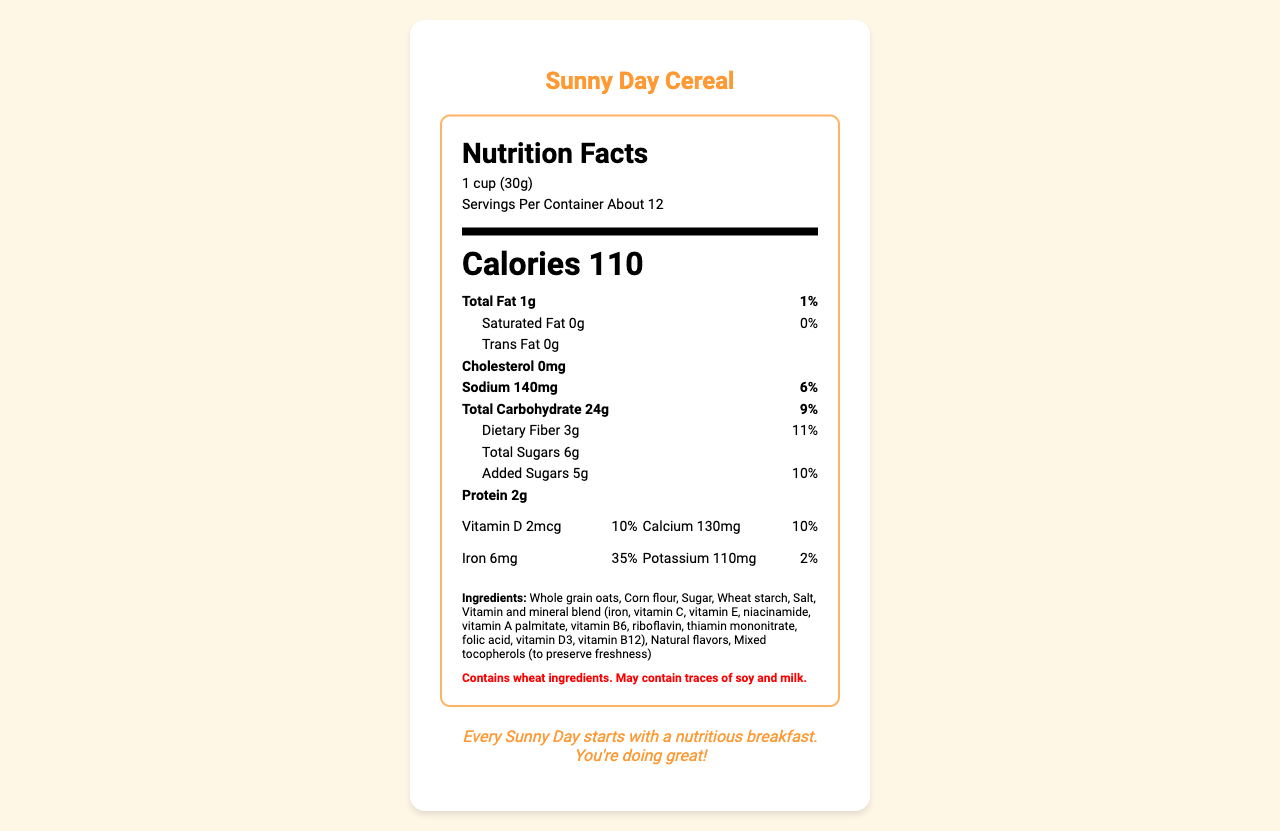what is the name of the product? The product name is displayed prominently at the top of the document.
Answer: Sunny Day Cereal how many servings are in the container? The number of servings per container is listed under the serving size information.
Answer: About 12 how many calories are in one serving? The number of calories per serving is listed prominently in bold near the top of the label.
Answer: 110 calories what is the serving size? The serving size is indicated below the title "Nutrition Facts."
Answer: 1 cup (30g) how much protein is in one serving? The protein content per serving is listed under the nutrition facts with other nutrients.
Answer: 2g what is the daily value percentage of iron in one serving? The percentage daily value of iron is listed under the vitamins section in the label.
Answer: 35% what vitamins and minerals are present in the cereal? A. Vitamin D, Calcium, Iron, Potassium B. Vitamin D, Calcium, Fiber, Vitamin A C. Potassium, Zinc, Fiber, Sugars D. Protein, Iron, Sugars, Potassium The listed nutrients include Vitamin D, Calcium, Iron, and Potassium.
Answer: A how much sodium is in one serving? A. 0mg B. 140mg C. 110mg D. 2mg The sodium content per serving is specified as 140mg.
Answer: B are there any artificial colors or flavors in the cereal? One of the marketing claims states "No artificial colors or flavors."
Answer: No is the breakfast cereal made with whole grains? One of the marketing claims states "Made with whole grains."
Answer: Yes what are some of the fun features for children? These features are listed under the child-friendly features section.
Answer: Colorful packaging with cartoon sun character, Fun, crunchy shapes, Mild, sweet flavor, Easy to eat with or without milk does the cereal contain any allergens? The allergen info mentions that the cereal contains wheat ingredients and may contain traces of soy and milk.
Answer: Yes summarize the main idea of the document. The document provides complete nutritional information, ingredients, allergen information, marketing claims, child-friendly features, and an emotional support message, summarizing all key aspects of the cereal.
Answer: Sunny Day Cereal is a vitamin-fortified breakfast cereal marketed to children, featuring whole grains, no artificial colors or flavors, and various child-friendly features. It provides essential nutrients in each serving and includes an emotional support message. what is the emotional support message on the label? The emotional support message is displayed at the end of the document.
Answer: Every Sunny Day starts with a nutritious breakfast. You're doing great! how many grams of dietary fiber are in one serving? The dietary fiber content is listed under the total carbohydrate section.
Answer: 3g how much total fat is in one serving? The total fat content per serving is displayed at the top of the nutrition facts section.
Answer: 1g what is the main ingredient in the cereal? The first ingredient listed is whole grain oats, indicating it is the main ingredient.
Answer: Whole grain oats what is the total carbohydrate content in one serving? The total carbohydrate content per serving is listed under the nutrition facts section.
Answer: 24g what is the source of vitamin and mineral blend mentioned in the ingredients? The document lists the vitamins and minerals but does not specify the source.
Answer: Not enough information what is the daily value percentage of Vitamin C in one serving? The percentage daily value of Vitamin C is listed in the vitamins section.
Answer: 10% 